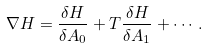<formula> <loc_0><loc_0><loc_500><loc_500>\nabla H = \frac { \delta H } { \delta A _ { 0 } } + T \frac { \delta H } { \delta A _ { 1 } } + \cdots .</formula> 